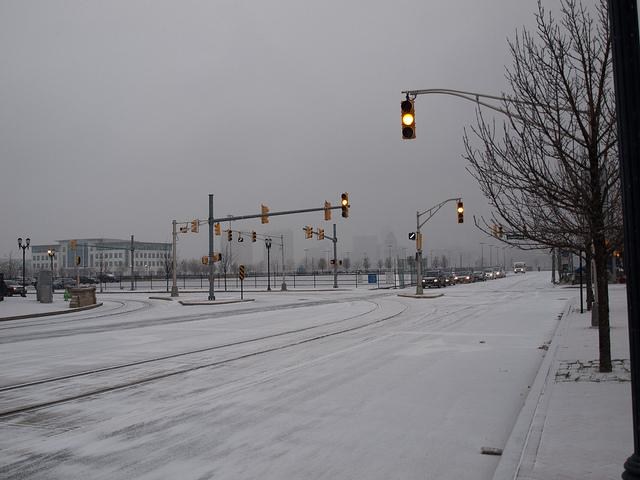Why has caused traffic to be so light on this roadway?

Choices:
A) flooding
B) rain
C) tornados
D) snow snow 